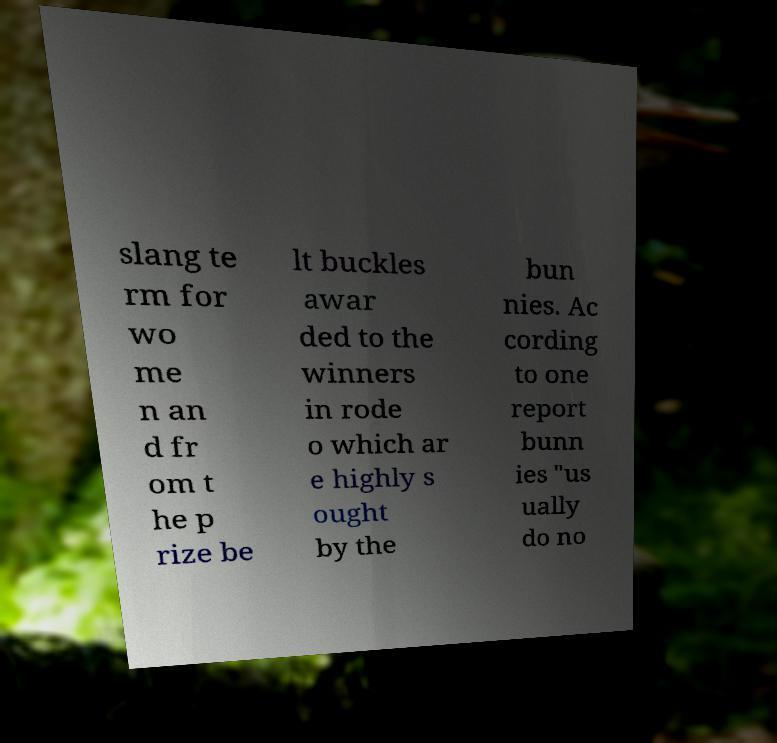There's text embedded in this image that I need extracted. Can you transcribe it verbatim? slang te rm for wo me n an d fr om t he p rize be lt buckles awar ded to the winners in rode o which ar e highly s ought by the bun nies. Ac cording to one report bunn ies "us ually do no 